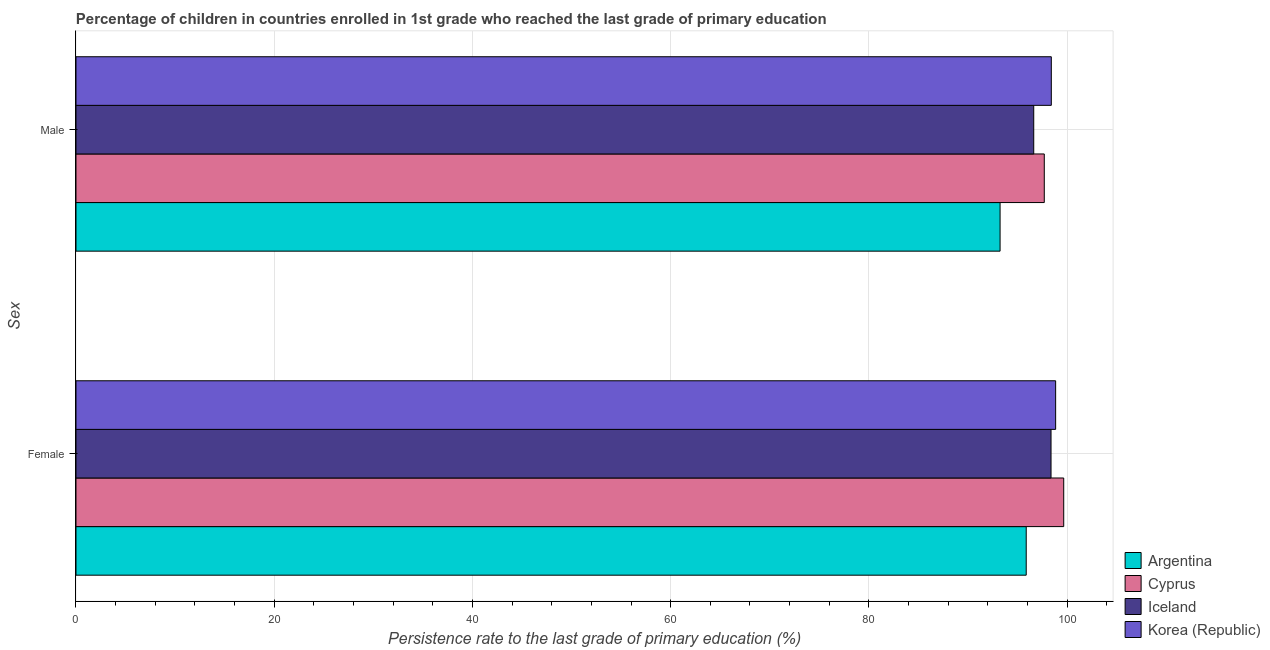How many groups of bars are there?
Your response must be concise. 2. Are the number of bars per tick equal to the number of legend labels?
Offer a very short reply. Yes. How many bars are there on the 1st tick from the top?
Keep it short and to the point. 4. How many bars are there on the 2nd tick from the bottom?
Give a very brief answer. 4. What is the label of the 2nd group of bars from the top?
Provide a short and direct response. Female. What is the persistence rate of female students in Korea (Republic)?
Offer a very short reply. 98.84. Across all countries, what is the maximum persistence rate of female students?
Give a very brief answer. 99.66. Across all countries, what is the minimum persistence rate of female students?
Your answer should be compact. 95.88. What is the total persistence rate of male students in the graph?
Your response must be concise. 385.98. What is the difference between the persistence rate of female students in Korea (Republic) and that in Argentina?
Offer a very short reply. 2.97. What is the difference between the persistence rate of female students in Korea (Republic) and the persistence rate of male students in Iceland?
Keep it short and to the point. 2.21. What is the average persistence rate of male students per country?
Your answer should be very brief. 96.49. What is the difference between the persistence rate of female students and persistence rate of male students in Iceland?
Provide a succinct answer. 1.74. In how many countries, is the persistence rate of female students greater than 100 %?
Your answer should be compact. 0. What is the ratio of the persistence rate of female students in Korea (Republic) to that in Cyprus?
Offer a very short reply. 0.99. Is the persistence rate of male students in Korea (Republic) less than that in Argentina?
Provide a succinct answer. No. In how many countries, is the persistence rate of female students greater than the average persistence rate of female students taken over all countries?
Your answer should be very brief. 3. What does the 3rd bar from the top in Male represents?
Your response must be concise. Cyprus. What does the 3rd bar from the bottom in Male represents?
Provide a succinct answer. Iceland. How many bars are there?
Make the answer very short. 8. What is the difference between two consecutive major ticks on the X-axis?
Your answer should be very brief. 20. Are the values on the major ticks of X-axis written in scientific E-notation?
Offer a terse response. No. Where does the legend appear in the graph?
Give a very brief answer. Bottom right. What is the title of the graph?
Keep it short and to the point. Percentage of children in countries enrolled in 1st grade who reached the last grade of primary education. Does "Jamaica" appear as one of the legend labels in the graph?
Offer a terse response. No. What is the label or title of the X-axis?
Give a very brief answer. Persistence rate to the last grade of primary education (%). What is the label or title of the Y-axis?
Offer a very short reply. Sex. What is the Persistence rate to the last grade of primary education (%) of Argentina in Female?
Give a very brief answer. 95.88. What is the Persistence rate to the last grade of primary education (%) of Cyprus in Female?
Your answer should be compact. 99.66. What is the Persistence rate to the last grade of primary education (%) in Iceland in Female?
Provide a succinct answer. 98.38. What is the Persistence rate to the last grade of primary education (%) in Korea (Republic) in Female?
Make the answer very short. 98.84. What is the Persistence rate to the last grade of primary education (%) of Argentina in Male?
Offer a terse response. 93.24. What is the Persistence rate to the last grade of primary education (%) in Cyprus in Male?
Your answer should be compact. 97.7. What is the Persistence rate to the last grade of primary education (%) in Iceland in Male?
Your response must be concise. 96.63. What is the Persistence rate to the last grade of primary education (%) of Korea (Republic) in Male?
Give a very brief answer. 98.41. Across all Sex, what is the maximum Persistence rate to the last grade of primary education (%) in Argentina?
Keep it short and to the point. 95.88. Across all Sex, what is the maximum Persistence rate to the last grade of primary education (%) in Cyprus?
Ensure brevity in your answer.  99.66. Across all Sex, what is the maximum Persistence rate to the last grade of primary education (%) of Iceland?
Offer a terse response. 98.38. Across all Sex, what is the maximum Persistence rate to the last grade of primary education (%) in Korea (Republic)?
Offer a terse response. 98.84. Across all Sex, what is the minimum Persistence rate to the last grade of primary education (%) in Argentina?
Your answer should be compact. 93.24. Across all Sex, what is the minimum Persistence rate to the last grade of primary education (%) of Cyprus?
Provide a short and direct response. 97.7. Across all Sex, what is the minimum Persistence rate to the last grade of primary education (%) of Iceland?
Provide a succinct answer. 96.63. Across all Sex, what is the minimum Persistence rate to the last grade of primary education (%) of Korea (Republic)?
Make the answer very short. 98.41. What is the total Persistence rate to the last grade of primary education (%) in Argentina in the graph?
Provide a short and direct response. 189.11. What is the total Persistence rate to the last grade of primary education (%) of Cyprus in the graph?
Provide a succinct answer. 197.36. What is the total Persistence rate to the last grade of primary education (%) of Iceland in the graph?
Your response must be concise. 195.01. What is the total Persistence rate to the last grade of primary education (%) in Korea (Republic) in the graph?
Make the answer very short. 197.25. What is the difference between the Persistence rate to the last grade of primary education (%) of Argentina in Female and that in Male?
Make the answer very short. 2.64. What is the difference between the Persistence rate to the last grade of primary education (%) of Cyprus in Female and that in Male?
Provide a succinct answer. 1.96. What is the difference between the Persistence rate to the last grade of primary education (%) in Iceland in Female and that in Male?
Make the answer very short. 1.75. What is the difference between the Persistence rate to the last grade of primary education (%) in Korea (Republic) in Female and that in Male?
Offer a terse response. 0.44. What is the difference between the Persistence rate to the last grade of primary education (%) of Argentina in Female and the Persistence rate to the last grade of primary education (%) of Cyprus in Male?
Give a very brief answer. -1.82. What is the difference between the Persistence rate to the last grade of primary education (%) in Argentina in Female and the Persistence rate to the last grade of primary education (%) in Iceland in Male?
Your answer should be compact. -0.76. What is the difference between the Persistence rate to the last grade of primary education (%) in Argentina in Female and the Persistence rate to the last grade of primary education (%) in Korea (Republic) in Male?
Give a very brief answer. -2.53. What is the difference between the Persistence rate to the last grade of primary education (%) in Cyprus in Female and the Persistence rate to the last grade of primary education (%) in Iceland in Male?
Offer a terse response. 3.02. What is the difference between the Persistence rate to the last grade of primary education (%) of Cyprus in Female and the Persistence rate to the last grade of primary education (%) of Korea (Republic) in Male?
Provide a succinct answer. 1.25. What is the difference between the Persistence rate to the last grade of primary education (%) in Iceland in Female and the Persistence rate to the last grade of primary education (%) in Korea (Republic) in Male?
Offer a terse response. -0.03. What is the average Persistence rate to the last grade of primary education (%) of Argentina per Sex?
Ensure brevity in your answer.  94.56. What is the average Persistence rate to the last grade of primary education (%) in Cyprus per Sex?
Provide a short and direct response. 98.68. What is the average Persistence rate to the last grade of primary education (%) of Iceland per Sex?
Your answer should be very brief. 97.51. What is the average Persistence rate to the last grade of primary education (%) of Korea (Republic) per Sex?
Offer a terse response. 98.63. What is the difference between the Persistence rate to the last grade of primary education (%) in Argentina and Persistence rate to the last grade of primary education (%) in Cyprus in Female?
Provide a succinct answer. -3.78. What is the difference between the Persistence rate to the last grade of primary education (%) of Argentina and Persistence rate to the last grade of primary education (%) of Iceland in Female?
Make the answer very short. -2.5. What is the difference between the Persistence rate to the last grade of primary education (%) in Argentina and Persistence rate to the last grade of primary education (%) in Korea (Republic) in Female?
Your answer should be very brief. -2.97. What is the difference between the Persistence rate to the last grade of primary education (%) in Cyprus and Persistence rate to the last grade of primary education (%) in Iceland in Female?
Make the answer very short. 1.28. What is the difference between the Persistence rate to the last grade of primary education (%) in Cyprus and Persistence rate to the last grade of primary education (%) in Korea (Republic) in Female?
Make the answer very short. 0.82. What is the difference between the Persistence rate to the last grade of primary education (%) of Iceland and Persistence rate to the last grade of primary education (%) of Korea (Republic) in Female?
Keep it short and to the point. -0.46. What is the difference between the Persistence rate to the last grade of primary education (%) in Argentina and Persistence rate to the last grade of primary education (%) in Cyprus in Male?
Your answer should be very brief. -4.46. What is the difference between the Persistence rate to the last grade of primary education (%) of Argentina and Persistence rate to the last grade of primary education (%) of Iceland in Male?
Ensure brevity in your answer.  -3.4. What is the difference between the Persistence rate to the last grade of primary education (%) of Argentina and Persistence rate to the last grade of primary education (%) of Korea (Republic) in Male?
Make the answer very short. -5.17. What is the difference between the Persistence rate to the last grade of primary education (%) in Cyprus and Persistence rate to the last grade of primary education (%) in Iceland in Male?
Give a very brief answer. 1.06. What is the difference between the Persistence rate to the last grade of primary education (%) of Cyprus and Persistence rate to the last grade of primary education (%) of Korea (Republic) in Male?
Your answer should be compact. -0.71. What is the difference between the Persistence rate to the last grade of primary education (%) of Iceland and Persistence rate to the last grade of primary education (%) of Korea (Republic) in Male?
Ensure brevity in your answer.  -1.77. What is the ratio of the Persistence rate to the last grade of primary education (%) of Argentina in Female to that in Male?
Your answer should be very brief. 1.03. What is the ratio of the Persistence rate to the last grade of primary education (%) in Cyprus in Female to that in Male?
Your response must be concise. 1.02. What is the ratio of the Persistence rate to the last grade of primary education (%) of Iceland in Female to that in Male?
Your response must be concise. 1.02. What is the ratio of the Persistence rate to the last grade of primary education (%) of Korea (Republic) in Female to that in Male?
Ensure brevity in your answer.  1. What is the difference between the highest and the second highest Persistence rate to the last grade of primary education (%) of Argentina?
Offer a terse response. 2.64. What is the difference between the highest and the second highest Persistence rate to the last grade of primary education (%) of Cyprus?
Offer a very short reply. 1.96. What is the difference between the highest and the second highest Persistence rate to the last grade of primary education (%) of Iceland?
Ensure brevity in your answer.  1.75. What is the difference between the highest and the second highest Persistence rate to the last grade of primary education (%) in Korea (Republic)?
Your response must be concise. 0.44. What is the difference between the highest and the lowest Persistence rate to the last grade of primary education (%) in Argentina?
Offer a terse response. 2.64. What is the difference between the highest and the lowest Persistence rate to the last grade of primary education (%) of Cyprus?
Your answer should be compact. 1.96. What is the difference between the highest and the lowest Persistence rate to the last grade of primary education (%) in Iceland?
Your response must be concise. 1.75. What is the difference between the highest and the lowest Persistence rate to the last grade of primary education (%) of Korea (Republic)?
Provide a succinct answer. 0.44. 